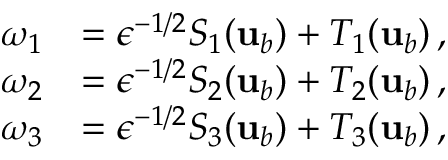Convert formula to latex. <formula><loc_0><loc_0><loc_500><loc_500>\begin{array} { r l } { \omega _ { 1 } } & { = \epsilon ^ { - 1 / 2 } S _ { 1 } ( { u } _ { b } ) + T _ { 1 } ( { u } _ { b } ) \, , } \\ { \omega _ { 2 } } & { = \epsilon ^ { - 1 / 2 } S _ { 2 } ( { u } _ { b } ) + T _ { 2 } ( { u } _ { b } ) \, , } \\ { \omega _ { 3 } } & { = \epsilon ^ { - 1 / 2 } S _ { 3 } ( { u } _ { b } ) + T _ { 3 } ( { u } _ { b } ) \, , } \end{array}</formula> 